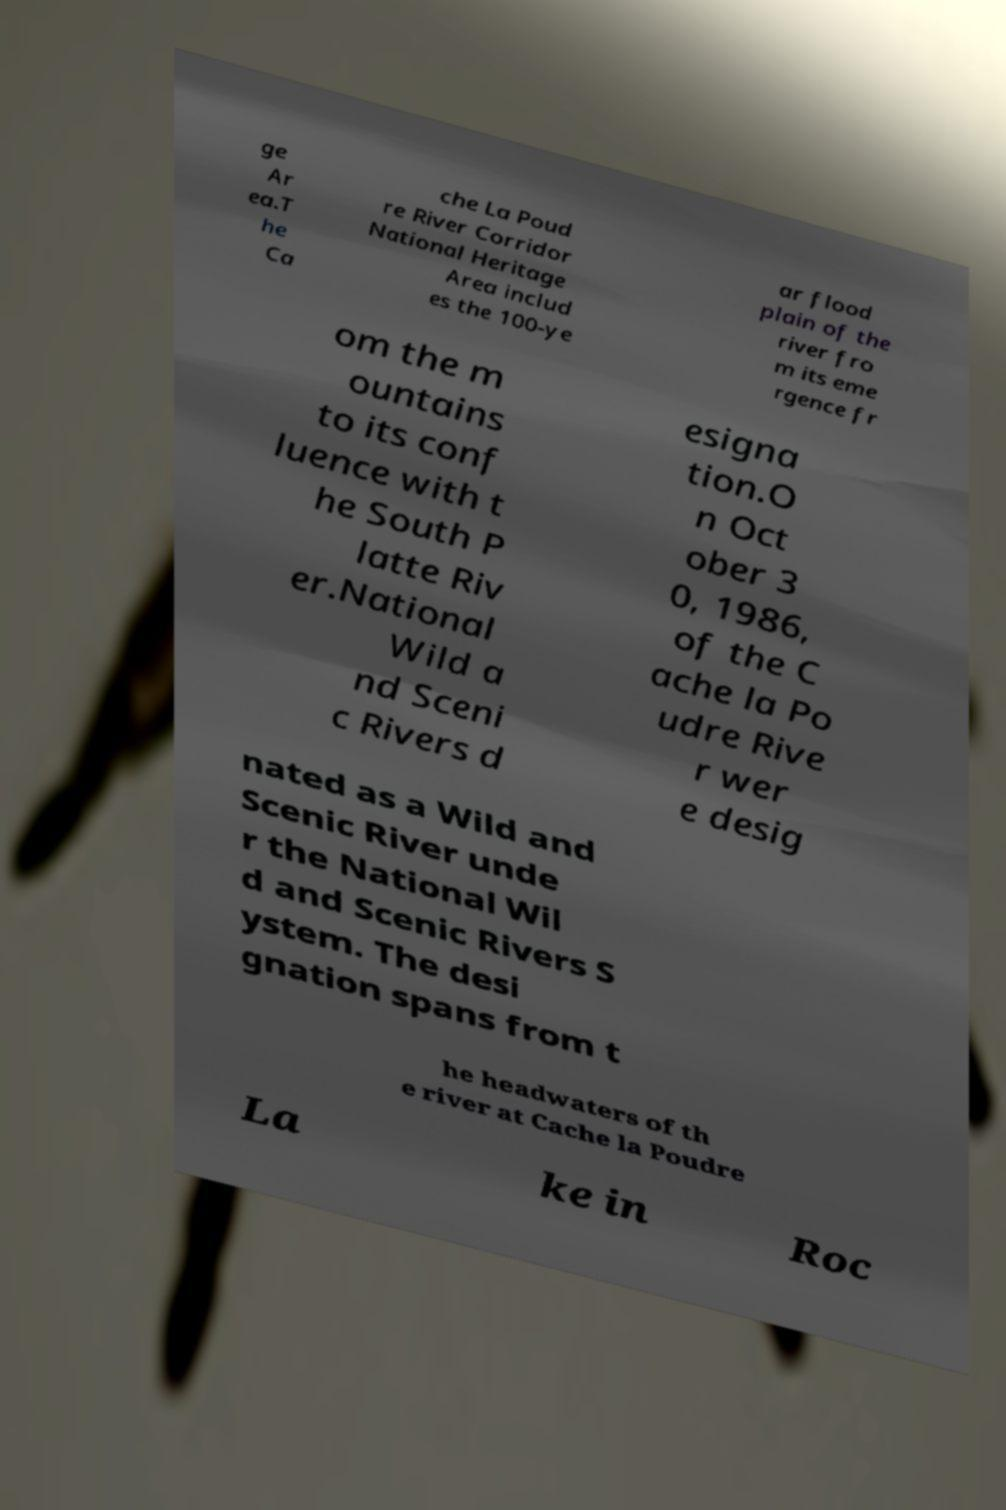Could you assist in decoding the text presented in this image and type it out clearly? ge Ar ea.T he Ca che La Poud re River Corridor National Heritage Area includ es the 100-ye ar flood plain of the river fro m its eme rgence fr om the m ountains to its conf luence with t he South P latte Riv er.National Wild a nd Sceni c Rivers d esigna tion.O n Oct ober 3 0, 1986, of the C ache la Po udre Rive r wer e desig nated as a Wild and Scenic River unde r the National Wil d and Scenic Rivers S ystem. The desi gnation spans from t he headwaters of th e river at Cache la Poudre La ke in Roc 